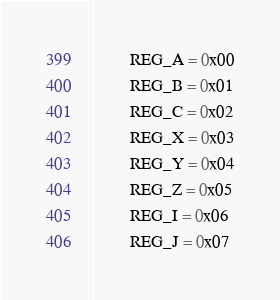<code> <loc_0><loc_0><loc_500><loc_500><_Cython_>		REG_A = 0x00
		REG_B = 0x01
		REG_C = 0x02
		REG_X = 0x03
		REG_Y = 0x04
		REG_Z = 0x05
		REG_I = 0x06
		REG_J = 0x07

</code> 